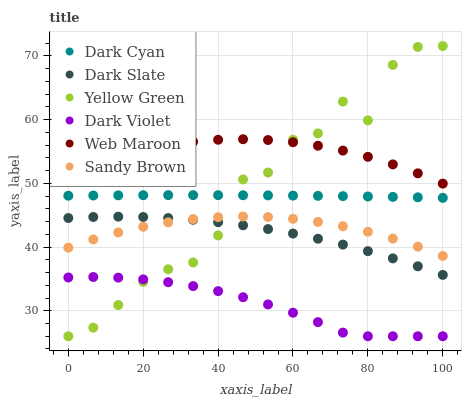Does Dark Violet have the minimum area under the curve?
Answer yes or no. Yes. Does Web Maroon have the maximum area under the curve?
Answer yes or no. Yes. Does Web Maroon have the minimum area under the curve?
Answer yes or no. No. Does Dark Violet have the maximum area under the curve?
Answer yes or no. No. Is Dark Cyan the smoothest?
Answer yes or no. Yes. Is Yellow Green the roughest?
Answer yes or no. Yes. Is Web Maroon the smoothest?
Answer yes or no. No. Is Web Maroon the roughest?
Answer yes or no. No. Does Yellow Green have the lowest value?
Answer yes or no. Yes. Does Web Maroon have the lowest value?
Answer yes or no. No. Does Yellow Green have the highest value?
Answer yes or no. Yes. Does Web Maroon have the highest value?
Answer yes or no. No. Is Dark Slate less than Dark Cyan?
Answer yes or no. Yes. Is Web Maroon greater than Dark Cyan?
Answer yes or no. Yes. Does Dark Slate intersect Sandy Brown?
Answer yes or no. Yes. Is Dark Slate less than Sandy Brown?
Answer yes or no. No. Is Dark Slate greater than Sandy Brown?
Answer yes or no. No. Does Dark Slate intersect Dark Cyan?
Answer yes or no. No. 